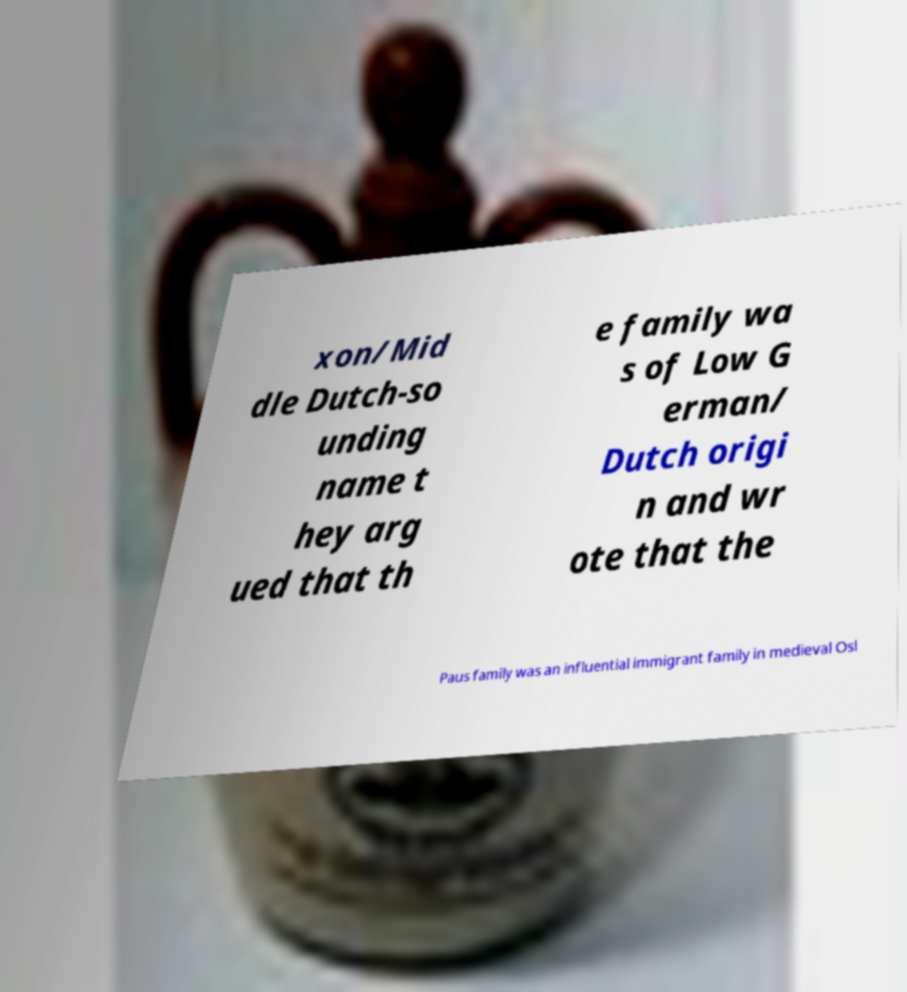Can you read and provide the text displayed in the image?This photo seems to have some interesting text. Can you extract and type it out for me? xon/Mid dle Dutch-so unding name t hey arg ued that th e family wa s of Low G erman/ Dutch origi n and wr ote that the Paus family was an influential immigrant family in medieval Osl 